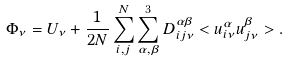Convert formula to latex. <formula><loc_0><loc_0><loc_500><loc_500>\Phi _ { \nu } = U _ { \nu } + \frac { 1 } { 2 N } \sum _ { i , j } ^ { N } \sum _ { \alpha , \beta } ^ { 3 } D _ { i j \nu } ^ { \alpha \beta } < u _ { i \nu } ^ { \alpha } u _ { j \nu } ^ { \beta } > .</formula> 